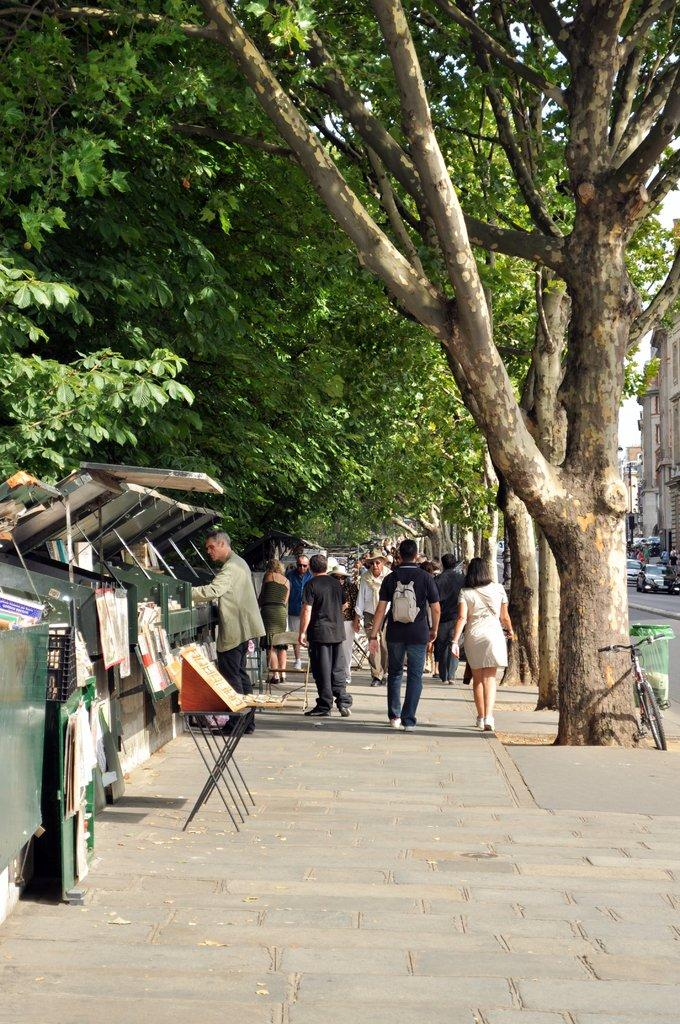What are the people in the image doing? The people in the image are walking on the side of the road. What can be seen on the side of the road besides the people? There are trees on the side of the road. What is visible on the right side of the image? There are buildings on the right side of the image. What else can be seen on the road? There are vehicles on the road. Can you tell me how many times the person in the image sneezed? There is no indication in the image that anyone sneezed, so it cannot be determined from the picture. 